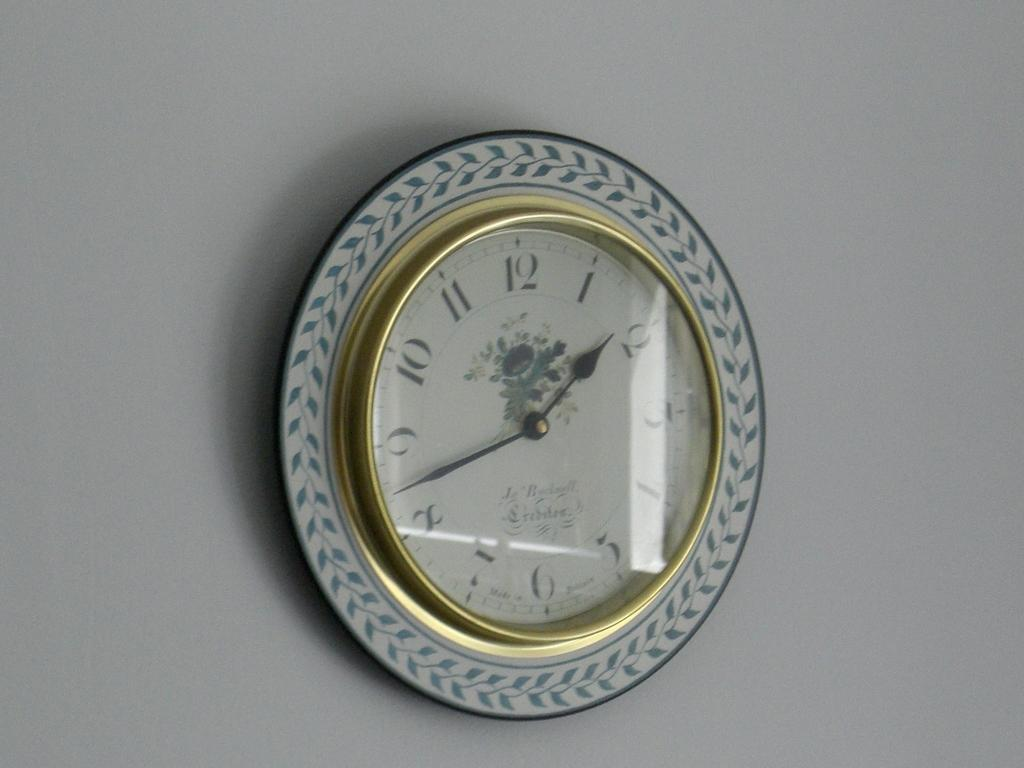<image>
Give a short and clear explanation of the subsequent image. a clock that has the number 12 on it 